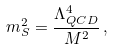<formula> <loc_0><loc_0><loc_500><loc_500>m _ { S } ^ { 2 } = \frac { \Lambda _ { Q C D } ^ { 4 } } { M ^ { 2 } } \, ,</formula> 